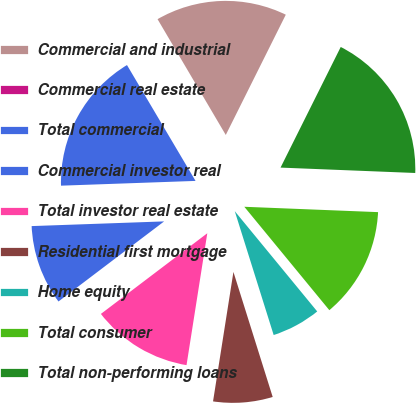Convert chart. <chart><loc_0><loc_0><loc_500><loc_500><pie_chart><fcel>Commercial and industrial<fcel>Commercial real estate<fcel>Total commercial<fcel>Commercial investor real<fcel>Total investor real estate<fcel>Residential first mortgage<fcel>Home equity<fcel>Total consumer<fcel>Total non-performing loans<nl><fcel>15.84%<fcel>0.03%<fcel>17.06%<fcel>9.76%<fcel>12.19%<fcel>7.33%<fcel>6.11%<fcel>13.41%<fcel>18.27%<nl></chart> 